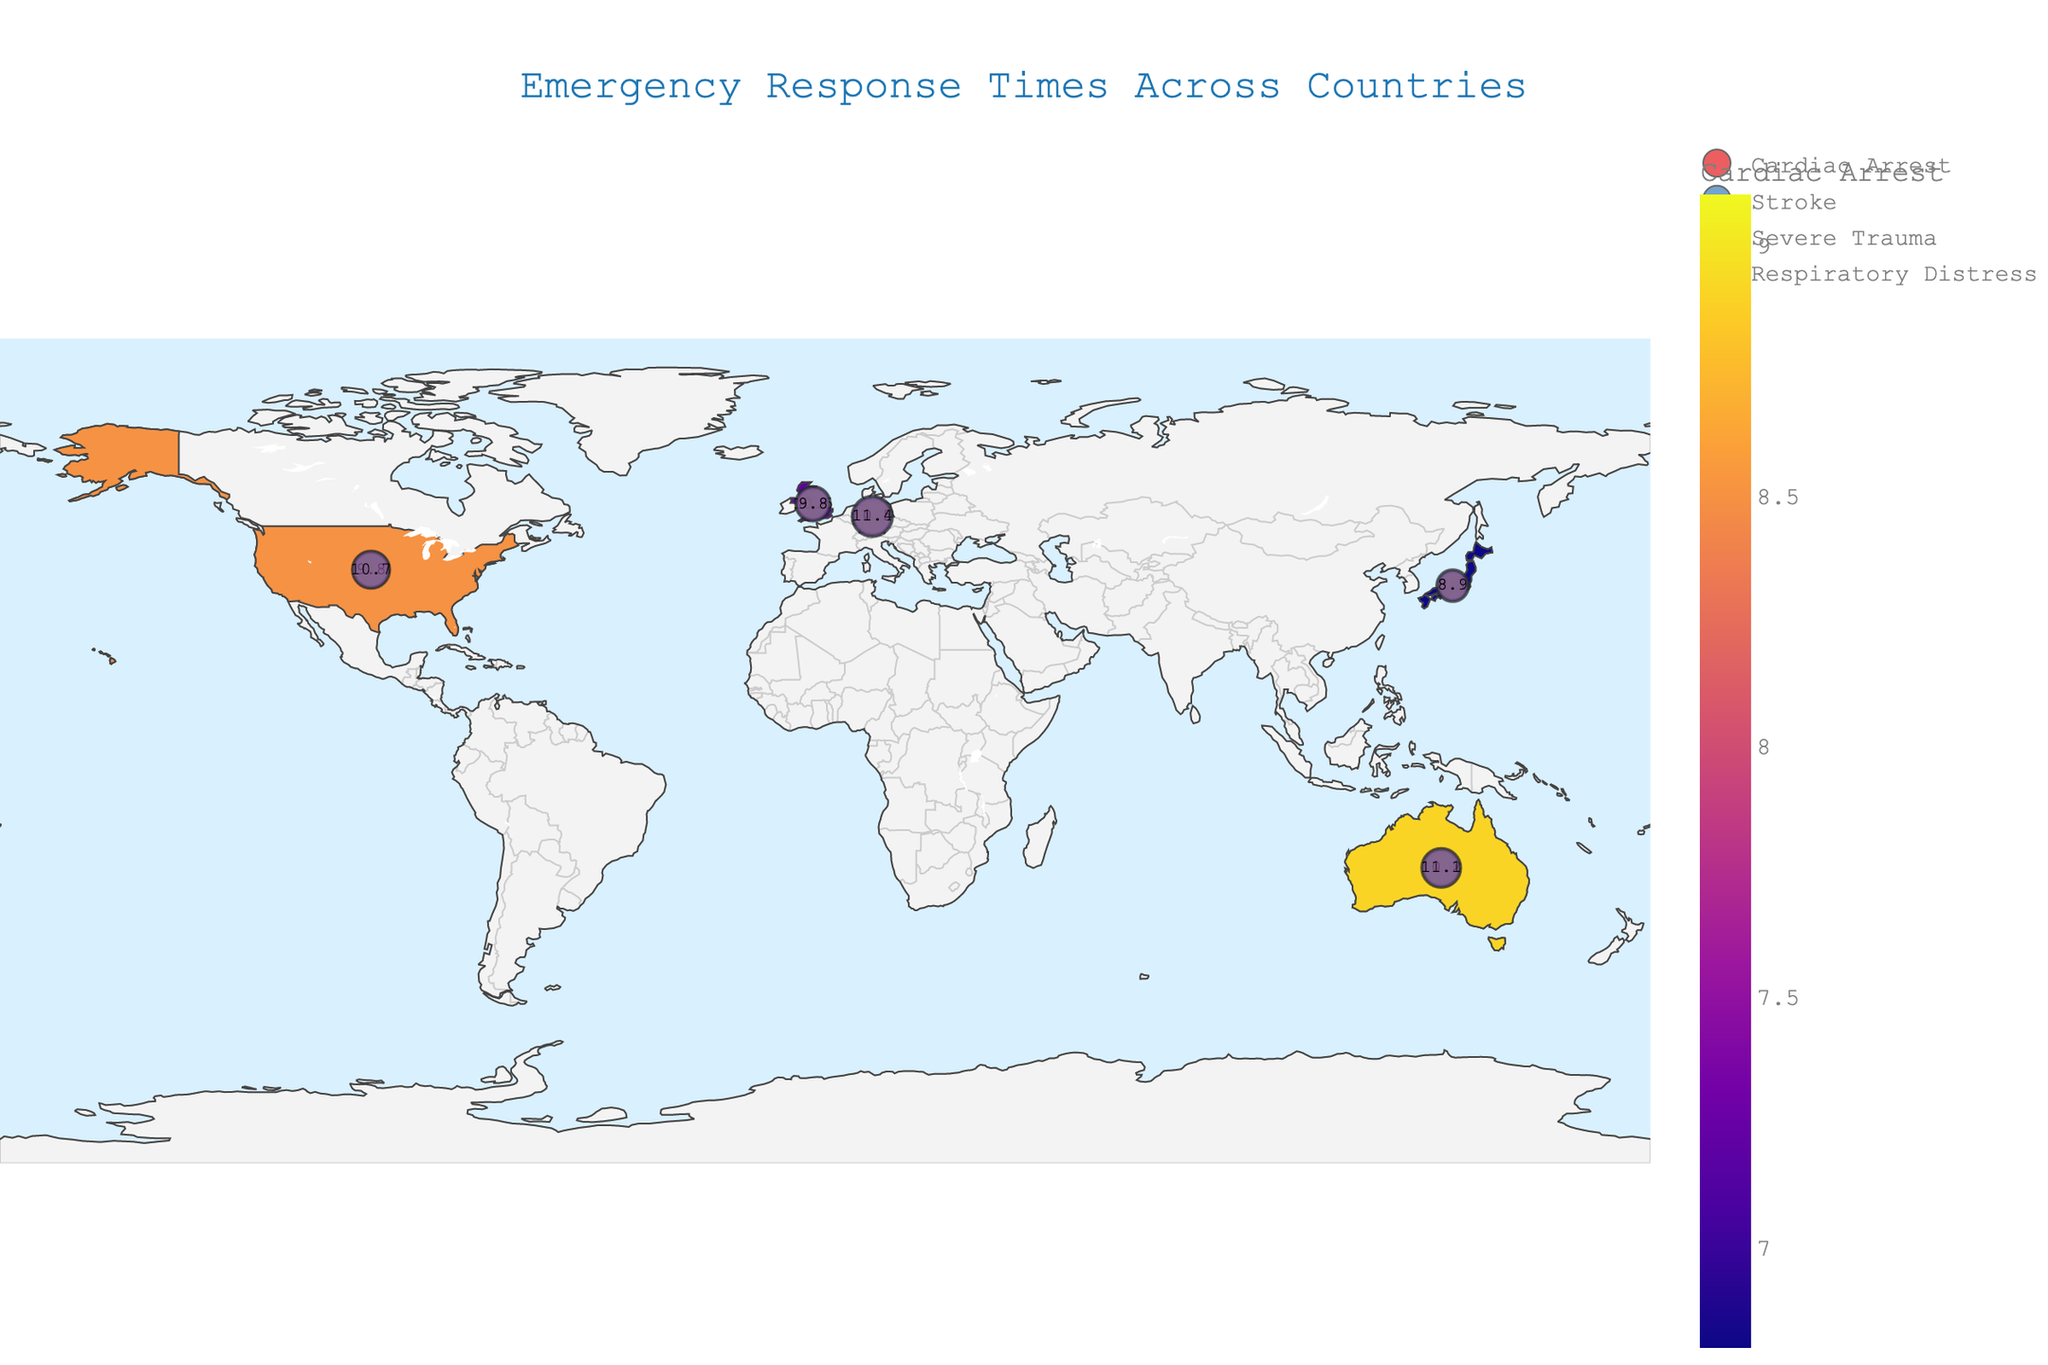What's the title of the figure? The title is usually displayed at the top of the figure. By looking at the rendered plot, you can identify the title.
Answer: Emergency Response Times Across Countries Which country has the lowest average response time for cardiac arrest? Locate the color associated with the lowest response time for cardiac arrest in the legend and identify the corresponding country on the map. The text markers can help clarify this.
Answer: Japan How does the average response time for severe trauma in Germany compare to that in Japan? Find the response times for severe trauma in both Germany and Japan. Subtract Japan's response time from Germany's response time to see the difference.
Answer: 2.4 minutes longer in Germany What is the average response time for respiratory distress emergencies across all countries? Find response times for respiratory distress in the visual. Add them and divide by the number of countries (5).
Answer: (10.7 + 9.8 + 8.9 + 11.4 + 11.1) / 5 = 10.38 minutes Which emergency type has the highest average response time in the United Kingdom? Look at the markers and data for the United Kingdom for each emergency type and compare the values to find the highest one.
Answer: Stroke By how much does Australia’s response time for severe trauma exceed Japan’s response time for the same emergency type? Find response times for severe trauma in Australia and Japan. Then, subtract Japan’s response time from Australia’s.
Answer: 2.1 minutes What is the overall trend for emergency response times across all countries? Observe the color gradients and size of the markers to see if there is a general trend (higher or lower) in emergency response times. This requires an overall comparison of the map.
Answer: Varies by country but generally higher response times for strokes Which country shows the most consistent emergency response times across different types of emergencies? Compare the range of response times within each country for different emergencies. The country with the smallest range of times is the most consistent.
Answer: Japan What is the difference between the fastest and slowest response times for respiratory distress shown on the map? Identify the fastest and slowest response times for respiratory distress by comparing the markers. Subtract the fastest response time from the slowest.
Answer: 11.4 - 8.9 = 2.5 minutes How does the response time for cardiac arrest in the United States compare to that in the United Kingdom? Find and compare the response times for cardiac arrest in both countries from the map and text markers.
Answer: 1.3 minutes longer in the United States 